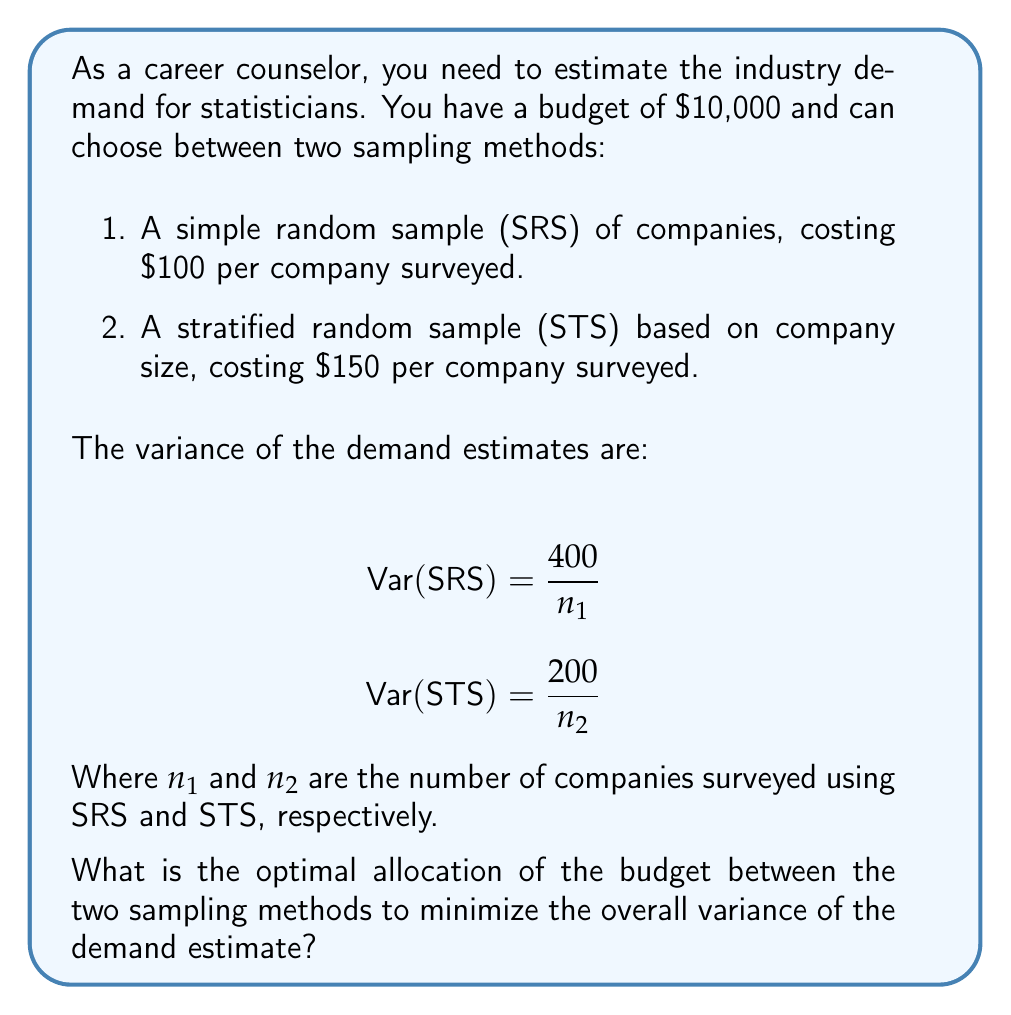What is the answer to this math problem? To solve this optimization problem, we need to minimize the overall variance while staying within the budget constraint. Let's approach this step-by-step:

1) First, let's define our objective function. The overall variance is the sum of the variances from both methods:

   $$\text{Var}(\text{Total}) = \frac{400}{n_1} + \frac{200}{n_2}$$

2) Our budget constraint is:

   $$100n_1 + 150n_2 \leq 10000$$

3) To find the optimal allocation, we can use the method of Lagrange multipliers. Let's define the Lagrangian:

   $$L(n_1, n_2, \lambda) = \frac{400}{n_1} + \frac{200}{n_2} + \lambda(100n_1 + 150n_2 - 10000)$$

4) Now, we take partial derivatives and set them to zero:

   $$\frac{\partial L}{\partial n_1} = -\frac{400}{n_1^2} + 100\lambda = 0$$
   $$\frac{\partial L}{\partial n_2} = -\frac{200}{n_2^2} + 150\lambda = 0$$
   $$\frac{\partial L}{\partial \lambda} = 100n_1 + 150n_2 - 10000 = 0$$

5) From the first two equations:

   $$\frac{400}{n_1^2} = 100\lambda \text{ and } \frac{200}{n_2^2} = 150\lambda$$

6) Dividing these equations:

   $$\frac{400}{n_1^2} \cdot \frac{n_2^2}{200} = \frac{100}{150}$$

   $$2n_2^2 = n_1^2$$

   $$n_2 = \frac{n_1}{\sqrt{2}}$$

7) Substituting this into the budget constraint:

   $$100n_1 + 150(\frac{n_1}{\sqrt{2}}) = 10000$$

   $$n_1(100 + \frac{150}{\sqrt{2}}) = 10000$$

   $$n_1 = \frac{10000}{100 + \frac{150}{\sqrt{2}}} \approx 71.71$$

8) Rounding to the nearest whole number (since we can't survey a fraction of a company):

   $$n_1 = 72$$
   $$n_2 = \frac{72}{\sqrt{2}} \approx 50.91 \approx 51$$

9) We can verify that this fits within our budget:

   $$72 * 100 + 51 * 150 = 7200 + 7650 = 9850 \leq 10000$$

Therefore, the optimal allocation is to survey 72 companies using SRS and 51 companies using STS.
Answer: The optimal allocation to minimize the overall variance of the demand estimate is to survey 72 companies using Simple Random Sampling (SRS) and 51 companies using Stratified Random Sampling (STS). 